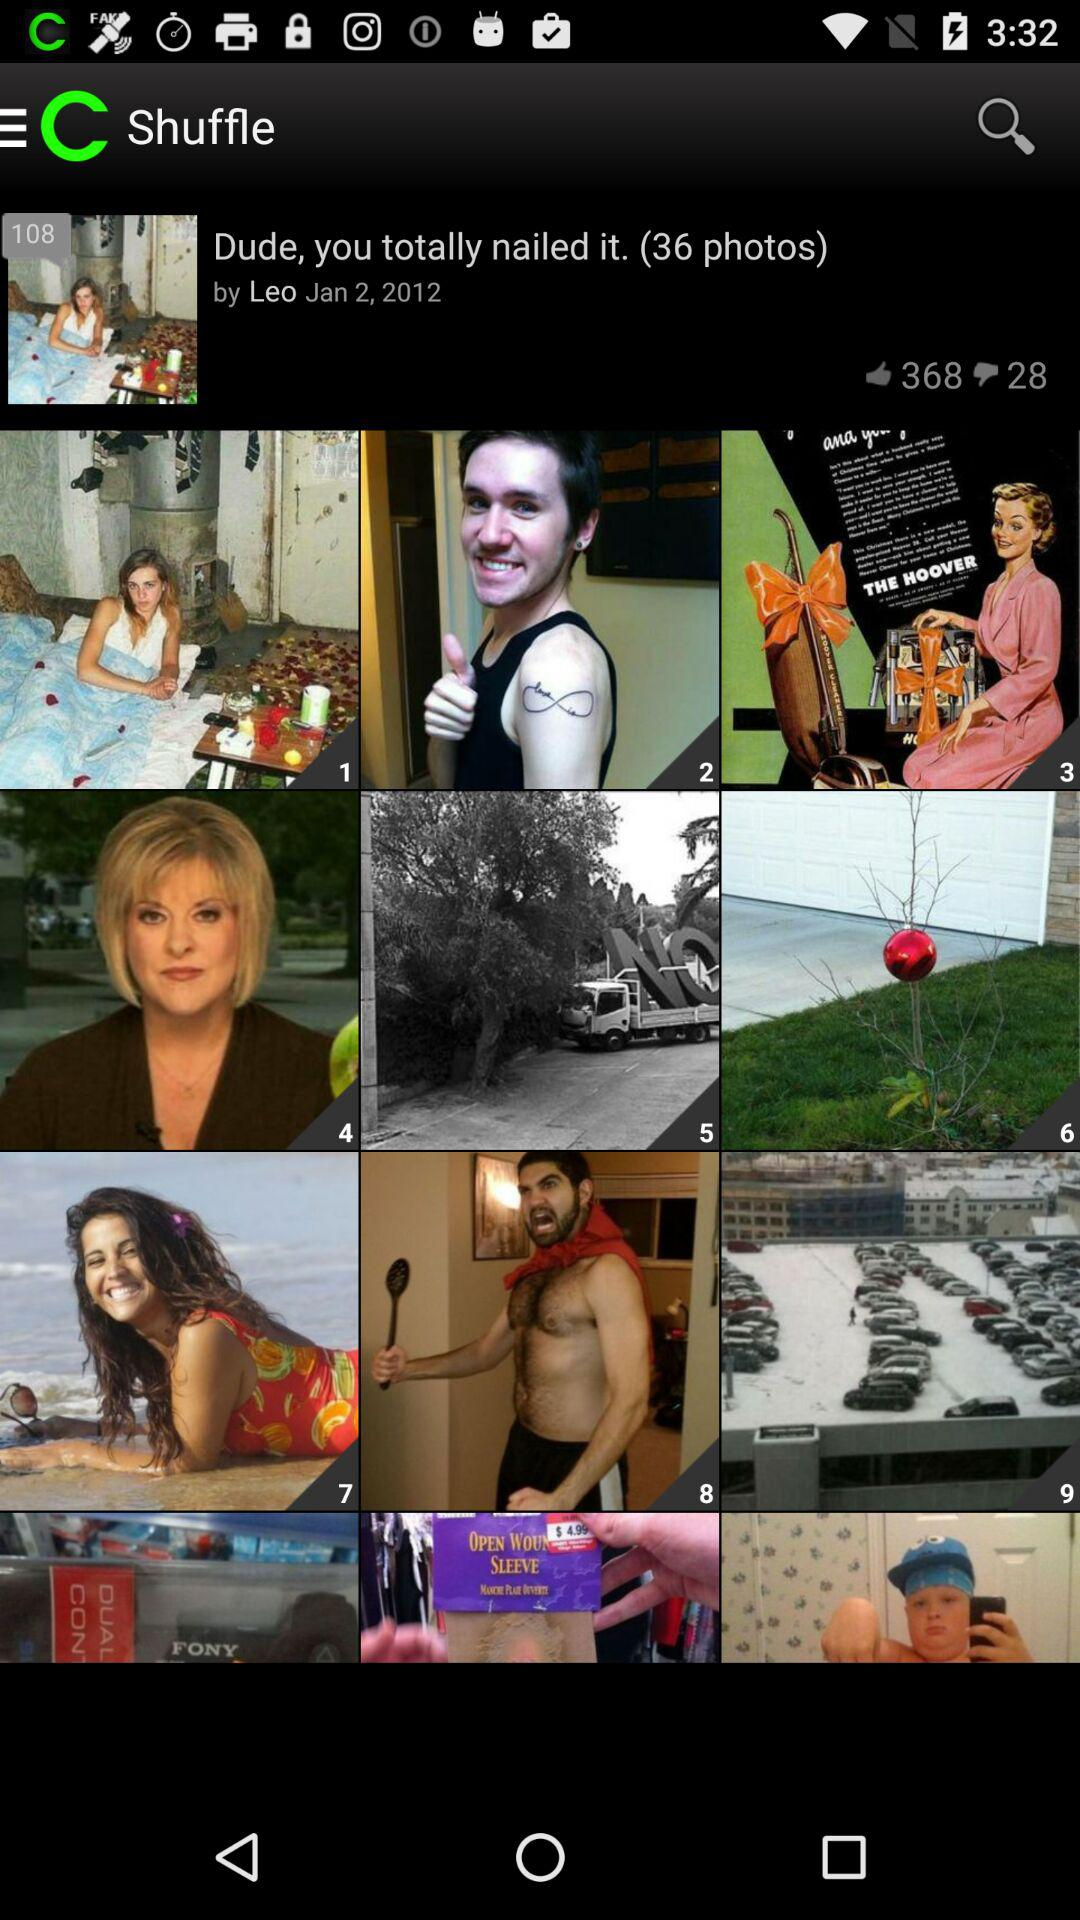What is the name of the photographer? The name of the photographer is Leo. 